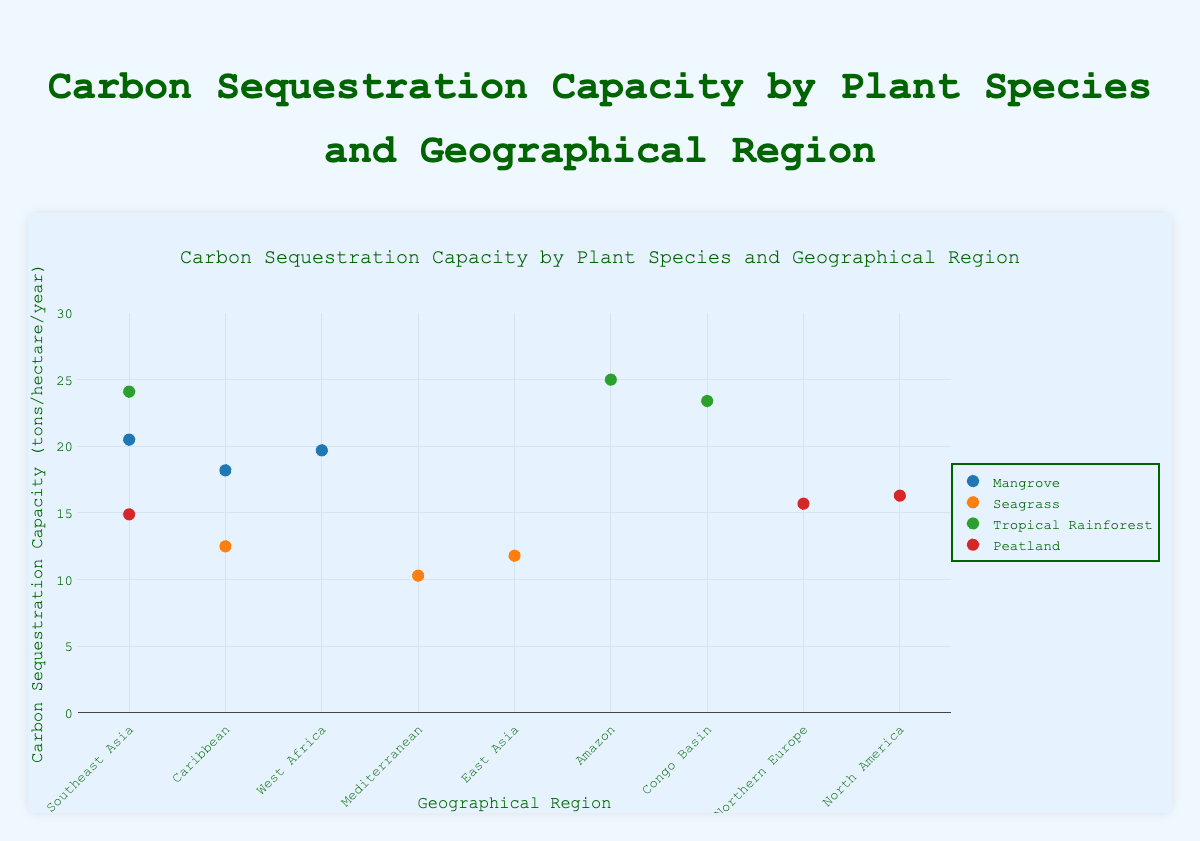What is the title of the figure? The title of the figure is located at the top and reads "Carbon Sequestration Capacity by Plant Species and Geographical Region".
Answer: Carbon Sequestration Capacity by Plant Species and Geographical Region What is the y-axis range of the figure? The y-axis range is indicated on the left, spanning from 0 to 30 tons/hectare/year.
Answer: 0 to 30 Which geographical region has the highest carbon sequestration capacity for Mangroves? By examining the y-values for Mangroves across the geographical regions, Southeast Asia has the highest value at 20.5 tons/hectare/year.
Answer: Southeast Asia What is the average carbon sequestration capacity of Seagrass across all regions? The values are (10.3, 12.5, 11.8). Summing these gives 34.6. There are 3 data points, so 34.6 / 3 equals approximately 11.53 tons/hectare/year.
Answer: 11.53 Which plant species has the maximum carbon sequestration capacity overall, and what is its value? By looking at the highest y-value across all data points, the Tropical Rainforest in the Amazon region has the maximum capacity of 25.0 tons/hectare/year.
Answer: Tropical Rainforest, 25.0 How does the carbon sequestration capacity of Peatlands in Northern Europe compare to that in Southeast Asia? The capacity in Northern Europe is 15.7 tons/hectare/year, while in Southeast Asia it is 14.9 tons/hectare/year. Therefore, Northern Europe has a higher capacity than Southeast Asia.
Answer: Northern Europe is higher Which combination of plant species and geographical region has the lowest carbon sequestration capacity? By identifying the lowest y-value across all points, Seagrass in the Mediterranean has the lowest value at 10.3 tons/hectare/year.
Answer: Seagrass, Mediterranean What is the difference in carbon sequestration capacity between Tropical Rainforest in the Congo Basin and Mangroves in the Caribbean? The capacity for the Tropical Rainforest in the Congo Basin is 23.4 tons/hectare/year, and for Mangroves in the Caribbean is 18.2 tons/hectare/year. The difference is 23.4 - 18.2 = 5.2 tons/hectare/year.
Answer: 5.2 What is the total carbon sequestration capacity of all regions for Peatlands? Adding the values for Peatlands across all regions: (15.7, 14.9, 16.3) gives 15.7 + 14.9 + 16.3 = 46.9 tons/hectare/year.
Answer: 46.9 